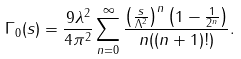<formula> <loc_0><loc_0><loc_500><loc_500>\Gamma _ { 0 } ( s ) = \frac { 9 \lambda ^ { 2 } } { 4 \pi ^ { 2 } } \sum _ { n = 0 } ^ { \infty } \frac { \left ( \frac { s } { \Lambda ^ { 2 } } \right ) ^ { n } \left ( 1 - \frac { 1 } { 2 ^ { n } } \right ) } { n ( ( n + 1 ) ! ) } .</formula> 